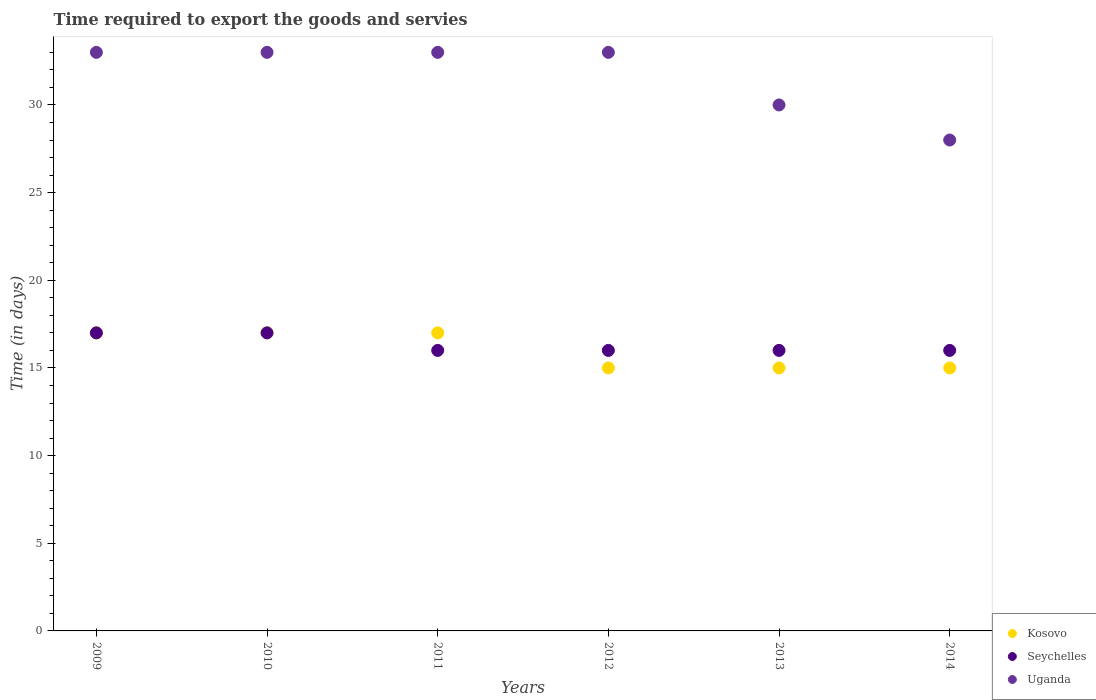How many different coloured dotlines are there?
Your answer should be very brief. 3. What is the number of days required to export the goods and services in Kosovo in 2012?
Your answer should be very brief. 15. Across all years, what is the maximum number of days required to export the goods and services in Seychelles?
Offer a very short reply. 17. Across all years, what is the minimum number of days required to export the goods and services in Kosovo?
Give a very brief answer. 15. In which year was the number of days required to export the goods and services in Kosovo minimum?
Ensure brevity in your answer.  2012. What is the total number of days required to export the goods and services in Seychelles in the graph?
Offer a terse response. 98. What is the difference between the number of days required to export the goods and services in Kosovo in 2013 and the number of days required to export the goods and services in Uganda in 2012?
Your answer should be very brief. -18. What is the average number of days required to export the goods and services in Uganda per year?
Your answer should be very brief. 31.67. Is the number of days required to export the goods and services in Uganda in 2010 less than that in 2012?
Give a very brief answer. No. What is the difference between the highest and the second highest number of days required to export the goods and services in Uganda?
Your answer should be very brief. 0. What is the difference between the highest and the lowest number of days required to export the goods and services in Uganda?
Your response must be concise. 5. In how many years, is the number of days required to export the goods and services in Seychelles greater than the average number of days required to export the goods and services in Seychelles taken over all years?
Offer a very short reply. 2. Is the number of days required to export the goods and services in Uganda strictly less than the number of days required to export the goods and services in Kosovo over the years?
Your response must be concise. No. How many dotlines are there?
Provide a succinct answer. 3. How many years are there in the graph?
Your response must be concise. 6. What is the difference between two consecutive major ticks on the Y-axis?
Your answer should be compact. 5. Are the values on the major ticks of Y-axis written in scientific E-notation?
Your answer should be compact. No. Does the graph contain grids?
Provide a succinct answer. No. Where does the legend appear in the graph?
Keep it short and to the point. Bottom right. How many legend labels are there?
Provide a short and direct response. 3. How are the legend labels stacked?
Offer a very short reply. Vertical. What is the title of the graph?
Provide a succinct answer. Time required to export the goods and servies. What is the label or title of the X-axis?
Offer a very short reply. Years. What is the label or title of the Y-axis?
Your answer should be very brief. Time (in days). What is the Time (in days) in Kosovo in 2009?
Make the answer very short. 17. What is the Time (in days) of Seychelles in 2009?
Keep it short and to the point. 17. What is the Time (in days) of Uganda in 2009?
Offer a very short reply. 33. What is the Time (in days) in Kosovo in 2010?
Provide a succinct answer. 17. What is the Time (in days) of Seychelles in 2010?
Ensure brevity in your answer.  17. What is the Time (in days) of Uganda in 2010?
Your response must be concise. 33. What is the Time (in days) in Kosovo in 2011?
Your response must be concise. 17. What is the Time (in days) in Uganda in 2011?
Your answer should be compact. 33. What is the Time (in days) in Seychelles in 2012?
Keep it short and to the point. 16. What is the Time (in days) of Uganda in 2014?
Give a very brief answer. 28. Across all years, what is the maximum Time (in days) of Kosovo?
Provide a short and direct response. 17. Across all years, what is the maximum Time (in days) of Seychelles?
Your response must be concise. 17. Across all years, what is the maximum Time (in days) of Uganda?
Provide a succinct answer. 33. What is the total Time (in days) in Kosovo in the graph?
Provide a short and direct response. 96. What is the total Time (in days) of Uganda in the graph?
Provide a short and direct response. 190. What is the difference between the Time (in days) in Seychelles in 2009 and that in 2011?
Offer a very short reply. 1. What is the difference between the Time (in days) in Kosovo in 2009 and that in 2012?
Offer a terse response. 2. What is the difference between the Time (in days) in Seychelles in 2009 and that in 2012?
Provide a succinct answer. 1. What is the difference between the Time (in days) of Uganda in 2009 and that in 2012?
Your answer should be compact. 0. What is the difference between the Time (in days) of Kosovo in 2009 and that in 2013?
Provide a short and direct response. 2. What is the difference between the Time (in days) in Seychelles in 2009 and that in 2014?
Keep it short and to the point. 1. What is the difference between the Time (in days) of Seychelles in 2010 and that in 2011?
Ensure brevity in your answer.  1. What is the difference between the Time (in days) of Seychelles in 2010 and that in 2012?
Ensure brevity in your answer.  1. What is the difference between the Time (in days) of Kosovo in 2010 and that in 2013?
Your response must be concise. 2. What is the difference between the Time (in days) of Uganda in 2010 and that in 2013?
Give a very brief answer. 3. What is the difference between the Time (in days) of Kosovo in 2010 and that in 2014?
Provide a succinct answer. 2. What is the difference between the Time (in days) in Uganda in 2010 and that in 2014?
Offer a terse response. 5. What is the difference between the Time (in days) of Kosovo in 2011 and that in 2013?
Ensure brevity in your answer.  2. What is the difference between the Time (in days) in Seychelles in 2011 and that in 2013?
Provide a succinct answer. 0. What is the difference between the Time (in days) in Uganda in 2011 and that in 2013?
Your answer should be compact. 3. What is the difference between the Time (in days) of Kosovo in 2011 and that in 2014?
Your answer should be very brief. 2. What is the difference between the Time (in days) of Uganda in 2011 and that in 2014?
Offer a terse response. 5. What is the difference between the Time (in days) of Seychelles in 2012 and that in 2013?
Make the answer very short. 0. What is the difference between the Time (in days) of Uganda in 2012 and that in 2013?
Keep it short and to the point. 3. What is the difference between the Time (in days) of Seychelles in 2012 and that in 2014?
Offer a terse response. 0. What is the difference between the Time (in days) of Kosovo in 2013 and that in 2014?
Provide a succinct answer. 0. What is the difference between the Time (in days) of Kosovo in 2009 and the Time (in days) of Seychelles in 2010?
Offer a terse response. 0. What is the difference between the Time (in days) of Kosovo in 2009 and the Time (in days) of Uganda in 2010?
Your answer should be very brief. -16. What is the difference between the Time (in days) in Seychelles in 2009 and the Time (in days) in Uganda in 2010?
Your answer should be very brief. -16. What is the difference between the Time (in days) of Kosovo in 2009 and the Time (in days) of Seychelles in 2011?
Offer a very short reply. 1. What is the difference between the Time (in days) in Kosovo in 2009 and the Time (in days) in Uganda in 2011?
Your response must be concise. -16. What is the difference between the Time (in days) in Kosovo in 2009 and the Time (in days) in Seychelles in 2012?
Keep it short and to the point. 1. What is the difference between the Time (in days) in Kosovo in 2009 and the Time (in days) in Uganda in 2012?
Make the answer very short. -16. What is the difference between the Time (in days) in Seychelles in 2009 and the Time (in days) in Uganda in 2012?
Your answer should be compact. -16. What is the difference between the Time (in days) in Kosovo in 2009 and the Time (in days) in Uganda in 2013?
Offer a terse response. -13. What is the difference between the Time (in days) of Kosovo in 2009 and the Time (in days) of Seychelles in 2014?
Your response must be concise. 1. What is the difference between the Time (in days) of Seychelles in 2009 and the Time (in days) of Uganda in 2014?
Offer a terse response. -11. What is the difference between the Time (in days) of Kosovo in 2010 and the Time (in days) of Seychelles in 2011?
Make the answer very short. 1. What is the difference between the Time (in days) of Kosovo in 2010 and the Time (in days) of Uganda in 2011?
Make the answer very short. -16. What is the difference between the Time (in days) of Seychelles in 2010 and the Time (in days) of Uganda in 2011?
Offer a very short reply. -16. What is the difference between the Time (in days) in Kosovo in 2010 and the Time (in days) in Uganda in 2012?
Your response must be concise. -16. What is the difference between the Time (in days) of Seychelles in 2010 and the Time (in days) of Uganda in 2012?
Your response must be concise. -16. What is the difference between the Time (in days) in Kosovo in 2010 and the Time (in days) in Seychelles in 2013?
Make the answer very short. 1. What is the difference between the Time (in days) in Kosovo in 2010 and the Time (in days) in Uganda in 2013?
Ensure brevity in your answer.  -13. What is the difference between the Time (in days) of Seychelles in 2010 and the Time (in days) of Uganda in 2013?
Keep it short and to the point. -13. What is the difference between the Time (in days) of Kosovo in 2011 and the Time (in days) of Uganda in 2012?
Provide a succinct answer. -16. What is the difference between the Time (in days) in Seychelles in 2011 and the Time (in days) in Uganda in 2012?
Offer a terse response. -17. What is the difference between the Time (in days) of Kosovo in 2011 and the Time (in days) of Seychelles in 2014?
Ensure brevity in your answer.  1. What is the difference between the Time (in days) in Seychelles in 2011 and the Time (in days) in Uganda in 2014?
Provide a short and direct response. -12. What is the difference between the Time (in days) in Kosovo in 2012 and the Time (in days) in Seychelles in 2013?
Keep it short and to the point. -1. What is the difference between the Time (in days) in Kosovo in 2012 and the Time (in days) in Uganda in 2013?
Provide a short and direct response. -15. What is the difference between the Time (in days) of Kosovo in 2013 and the Time (in days) of Seychelles in 2014?
Provide a short and direct response. -1. What is the difference between the Time (in days) of Kosovo in 2013 and the Time (in days) of Uganda in 2014?
Make the answer very short. -13. What is the difference between the Time (in days) of Seychelles in 2013 and the Time (in days) of Uganda in 2014?
Provide a short and direct response. -12. What is the average Time (in days) in Kosovo per year?
Ensure brevity in your answer.  16. What is the average Time (in days) of Seychelles per year?
Give a very brief answer. 16.33. What is the average Time (in days) in Uganda per year?
Your answer should be very brief. 31.67. In the year 2009, what is the difference between the Time (in days) of Kosovo and Time (in days) of Seychelles?
Offer a very short reply. 0. In the year 2009, what is the difference between the Time (in days) in Seychelles and Time (in days) in Uganda?
Offer a very short reply. -16. In the year 2011, what is the difference between the Time (in days) in Seychelles and Time (in days) in Uganda?
Your response must be concise. -17. In the year 2012, what is the difference between the Time (in days) in Kosovo and Time (in days) in Uganda?
Your response must be concise. -18. In the year 2012, what is the difference between the Time (in days) of Seychelles and Time (in days) of Uganda?
Ensure brevity in your answer.  -17. In the year 2013, what is the difference between the Time (in days) of Kosovo and Time (in days) of Seychelles?
Make the answer very short. -1. In the year 2013, what is the difference between the Time (in days) of Seychelles and Time (in days) of Uganda?
Provide a short and direct response. -14. In the year 2014, what is the difference between the Time (in days) in Kosovo and Time (in days) in Seychelles?
Your answer should be very brief. -1. In the year 2014, what is the difference between the Time (in days) in Seychelles and Time (in days) in Uganda?
Your response must be concise. -12. What is the ratio of the Time (in days) of Seychelles in 2009 to that in 2010?
Provide a succinct answer. 1. What is the ratio of the Time (in days) in Kosovo in 2009 to that in 2012?
Give a very brief answer. 1.13. What is the ratio of the Time (in days) of Uganda in 2009 to that in 2012?
Give a very brief answer. 1. What is the ratio of the Time (in days) of Kosovo in 2009 to that in 2013?
Your response must be concise. 1.13. What is the ratio of the Time (in days) of Seychelles in 2009 to that in 2013?
Ensure brevity in your answer.  1.06. What is the ratio of the Time (in days) in Uganda in 2009 to that in 2013?
Ensure brevity in your answer.  1.1. What is the ratio of the Time (in days) in Kosovo in 2009 to that in 2014?
Offer a terse response. 1.13. What is the ratio of the Time (in days) in Uganda in 2009 to that in 2014?
Make the answer very short. 1.18. What is the ratio of the Time (in days) of Kosovo in 2010 to that in 2011?
Offer a very short reply. 1. What is the ratio of the Time (in days) in Uganda in 2010 to that in 2011?
Your answer should be compact. 1. What is the ratio of the Time (in days) of Kosovo in 2010 to that in 2012?
Your response must be concise. 1.13. What is the ratio of the Time (in days) in Seychelles in 2010 to that in 2012?
Keep it short and to the point. 1.06. What is the ratio of the Time (in days) in Kosovo in 2010 to that in 2013?
Offer a terse response. 1.13. What is the ratio of the Time (in days) of Seychelles in 2010 to that in 2013?
Keep it short and to the point. 1.06. What is the ratio of the Time (in days) of Uganda in 2010 to that in 2013?
Provide a short and direct response. 1.1. What is the ratio of the Time (in days) of Kosovo in 2010 to that in 2014?
Offer a very short reply. 1.13. What is the ratio of the Time (in days) in Uganda in 2010 to that in 2014?
Provide a succinct answer. 1.18. What is the ratio of the Time (in days) in Kosovo in 2011 to that in 2012?
Your response must be concise. 1.13. What is the ratio of the Time (in days) in Kosovo in 2011 to that in 2013?
Give a very brief answer. 1.13. What is the ratio of the Time (in days) of Seychelles in 2011 to that in 2013?
Keep it short and to the point. 1. What is the ratio of the Time (in days) of Kosovo in 2011 to that in 2014?
Keep it short and to the point. 1.13. What is the ratio of the Time (in days) in Seychelles in 2011 to that in 2014?
Your response must be concise. 1. What is the ratio of the Time (in days) of Uganda in 2011 to that in 2014?
Ensure brevity in your answer.  1.18. What is the ratio of the Time (in days) in Kosovo in 2012 to that in 2013?
Your answer should be very brief. 1. What is the ratio of the Time (in days) in Seychelles in 2012 to that in 2013?
Your answer should be very brief. 1. What is the ratio of the Time (in days) of Uganda in 2012 to that in 2013?
Your answer should be compact. 1.1. What is the ratio of the Time (in days) in Kosovo in 2012 to that in 2014?
Your answer should be very brief. 1. What is the ratio of the Time (in days) of Uganda in 2012 to that in 2014?
Provide a succinct answer. 1.18. What is the ratio of the Time (in days) of Kosovo in 2013 to that in 2014?
Ensure brevity in your answer.  1. What is the ratio of the Time (in days) of Seychelles in 2013 to that in 2014?
Provide a short and direct response. 1. What is the ratio of the Time (in days) in Uganda in 2013 to that in 2014?
Your answer should be compact. 1.07. What is the difference between the highest and the second highest Time (in days) in Uganda?
Provide a short and direct response. 0. What is the difference between the highest and the lowest Time (in days) of Seychelles?
Your answer should be very brief. 1. 